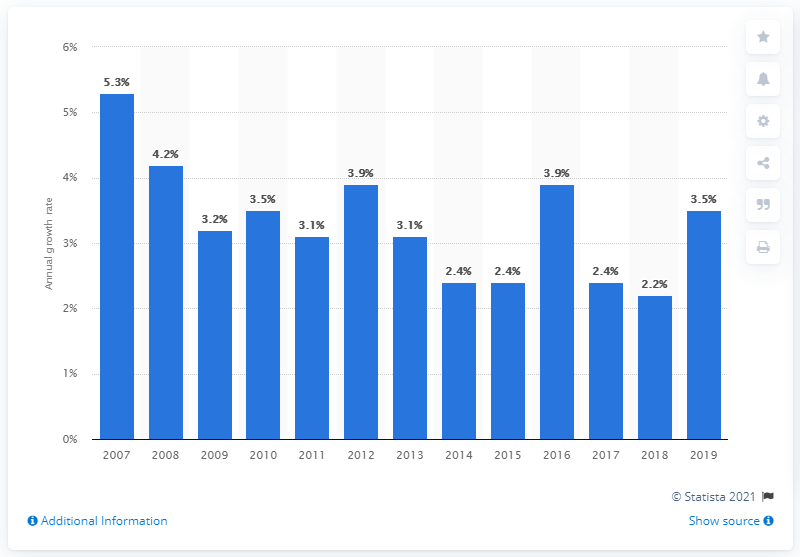Highlight a few significant elements in this photo. The Consumer Price Index (CPI) for medical care services in cities in the United States increased by 5.3% in 2007. 